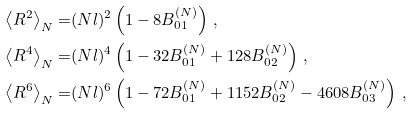<formula> <loc_0><loc_0><loc_500><loc_500>\left \langle R ^ { 2 } \right \rangle _ { N } = & ( N l ) ^ { 2 } \left ( 1 - 8 B _ { 0 1 } ^ { ( N ) } \right ) \, , \\ \left \langle R ^ { 4 } \right \rangle _ { N } = & ( N l ) ^ { 4 } \left ( 1 - 3 2 B _ { 0 1 } ^ { ( N ) } + 1 2 8 B _ { 0 2 } ^ { ( N ) } \right ) \, , \\ \left \langle R ^ { 6 } \right \rangle _ { N } = & ( N l ) ^ { 6 } \left ( 1 - 7 2 B _ { 0 1 } ^ { ( N ) } + 1 1 5 2 B _ { 0 2 } ^ { ( N ) } - 4 6 0 8 B _ { 0 3 } ^ { ( N ) } \right ) \, ,</formula> 